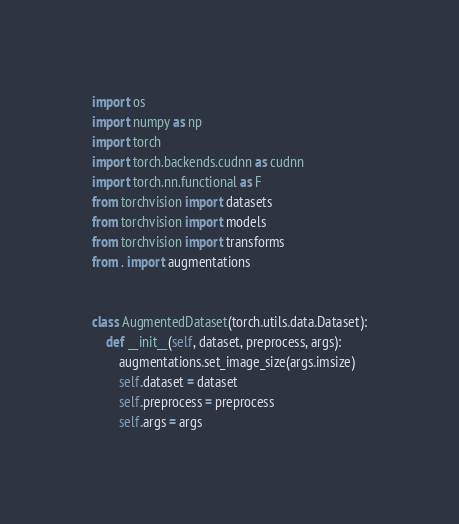<code> <loc_0><loc_0><loc_500><loc_500><_Python_>import os
import numpy as np
import torch
import torch.backends.cudnn as cudnn
import torch.nn.functional as F
from torchvision import datasets
from torchvision import models
from torchvision import transforms
from . import augmentations


class AugmentedDataset(torch.utils.data.Dataset):
    def __init__(self, dataset, preprocess, args):
        augmentations.set_image_size(args.imsize)
        self.dataset = dataset
        self.preprocess = preprocess
        self.args = args</code> 